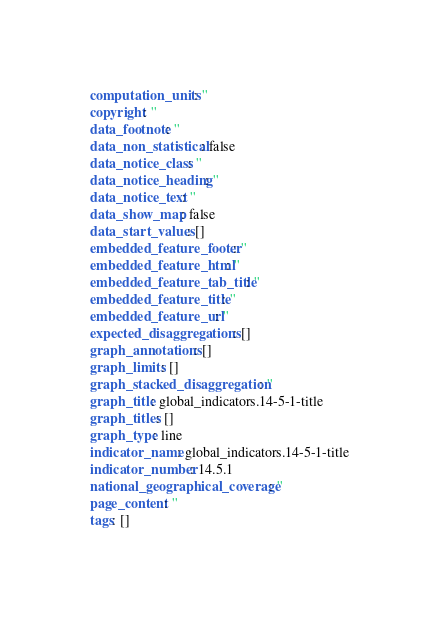<code> <loc_0><loc_0><loc_500><loc_500><_YAML_>computation_units: ''
copyright: ''
data_footnote: ''
data_non_statistical: false
data_notice_class: ''
data_notice_heading: ''
data_notice_text: ''
data_show_map: false
data_start_values: []
embedded_feature_footer: ''
embedded_feature_html: ''
embedded_feature_tab_title: ''
embedded_feature_title: ''
embedded_feature_url: ''
expected_disaggregations: []
graph_annotations: []
graph_limits: []
graph_stacked_disaggregation: ''
graph_title: global_indicators.14-5-1-title
graph_titles: []
graph_type: line
indicator_name: global_indicators.14-5-1-title
indicator_number: 14.5.1
national_geographical_coverage: ''
page_content: ''
tags: []
</code> 